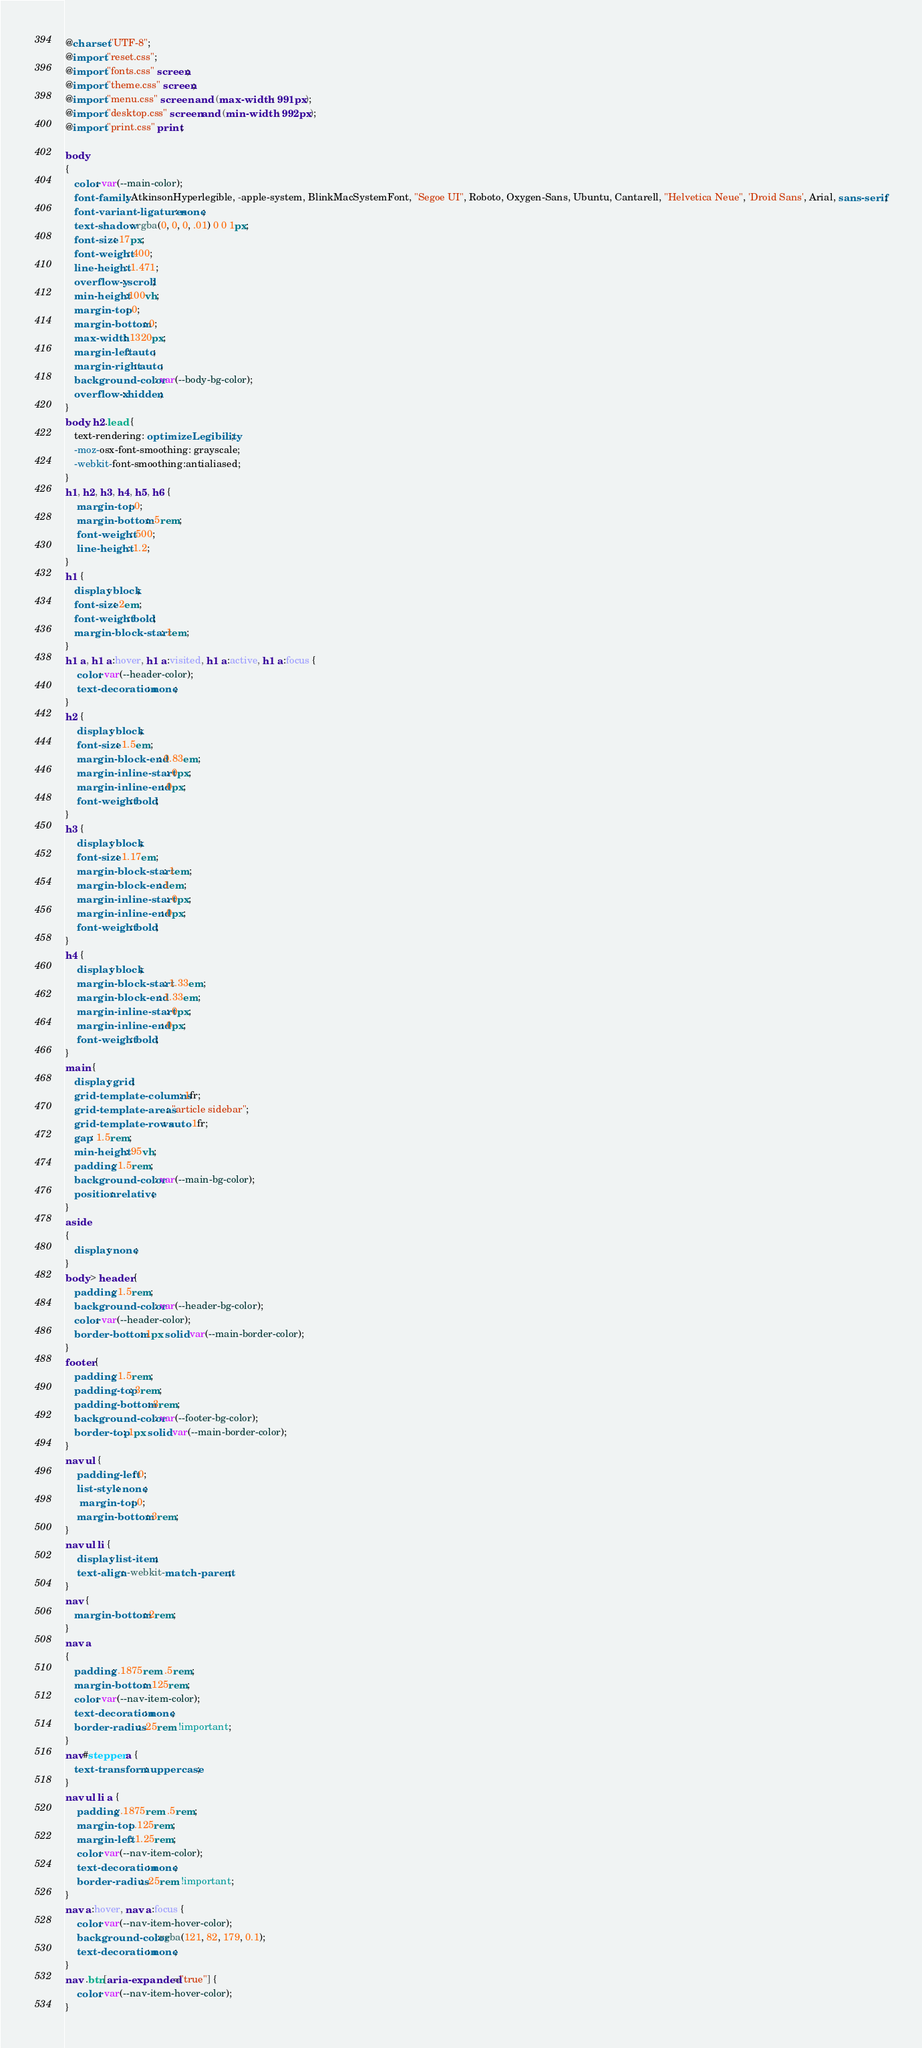<code> <loc_0><loc_0><loc_500><loc_500><_CSS_>@charset "UTF-8";
@import "reset.css";
@import "fonts.css" screen;
@import "theme.css" screen;
@import "menu.css" screen  and (max-width : 991px);
@import "desktop.css" screen and (min-width : 992px);
@import "print.css" print;

body
{
   color: var(--main-color);
   font-family: AtkinsonHyperlegible, -apple-system, BlinkMacSystemFont, "Segoe UI", Roboto, Oxygen-Sans, Ubuntu, Cantarell, "Helvetica Neue", 'Droid Sans', Arial, sans-serif;
   font-variant-ligatures: none;
   text-shadow: rgba(0, 0, 0, .01) 0 0 1px;
   font-size: 17px;
   font-weight: 400;
   line-height: 1.471;
   overflow-y: scroll;
   min-height:100vh;
   margin-top: 0;
   margin-bottom: 0;
   max-width: 1320px;
   margin-left: auto;
   margin-right: auto;
   background-color: var(--body-bg-color);
   overflow-x: hidden;
}
body, h2.lead {
   text-rendering: optimizeLegibility;
   -moz-osx-font-smoothing: grayscale;
   -webkit-font-smoothing:antialiased;
}
h1, h2, h3, h4, h5, h6 {
    margin-top: 0;
    margin-bottom: .5rem;
    font-weight: 500;
    line-height: 1.2;
}
h1 {
   display: block;
   font-size: 2em;
   font-weight: bold;
   margin-block-start: 1em;
}
h1 a, h1 a:hover, h1 a:visited, h1 a:active, h1 a:focus {
    color: var(--header-color);
    text-decoration: none;
}
h2 {
    display: block;
    font-size: 1.5em;
    margin-block-end: 0.83em;
    margin-inline-start: 0px;
    margin-inline-end: 0px;
    font-weight: bold;
}
h3 {
    display: block;
    font-size: 1.17em;
    margin-block-start: 1em;
    margin-block-end: 1em;
    margin-inline-start: 0px;
    margin-inline-end: 0px;
    font-weight: bold;
}
h4 {
    display: block;
    margin-block-start: 1.33em;
    margin-block-end: 1.33em;
    margin-inline-start: 0px;
    margin-inline-end: 0px;
    font-weight: bold;
}
main {
   display: grid;
   grid-template-columns: 1fr;
   grid-template-areas: "article sidebar";
   grid-template-rows: auto 1fr;
   gap: 1.5rem;
   min-height: 95vh;
   padding: 1.5rem;
   background-color: var(--main-bg-color);
   position: relative;
}
aside
{
   display: none;
}
body > header {
   padding: 1.5rem;
   background-color: var(--header-bg-color);
   color: var(--header-color);
   border-bottom: 1px solid var(--main-border-color);
}
footer {
   padding: 1.5rem;
   padding-top: 3rem;
   padding-bottom: 3rem;
   background-color: var(--footer-bg-color);
   border-top: 1px solid var(--main-border-color);
}
nav ul {
    padding-left: 0;
    list-style: none;
     margin-top: 0;
    margin-bottom: 3rem;
}
nav ul li {
    display: list-item;
    text-align: -webkit-match-parent;
}
nav {
   margin-bottom: 2rem;
}
nav a
{
   padding: .1875rem .5rem;
   margin-bottom: .125rem;
   color: var(--nav-item-color);
   text-decoration: none;
   border-radius: .25rem !important;
}
nav#stepper a {
   text-transform : uppercase;
}
nav ul li a {
    padding: .1875rem .5rem;
    margin-top: .125rem;
    margin-left: 1.25rem;
    color: var(--nav-item-color);
    text-decoration: none;
    border-radius: .25rem !important;
}
nav a:hover, nav a:focus {
    color: var(--nav-item-hover-color);
    background-color:rgba(121, 82, 179, 0.1);
    text-decoration: none;
}
nav .btn[aria-expanded="true"] {
    color: var(--nav-item-hover-color);
}</code> 